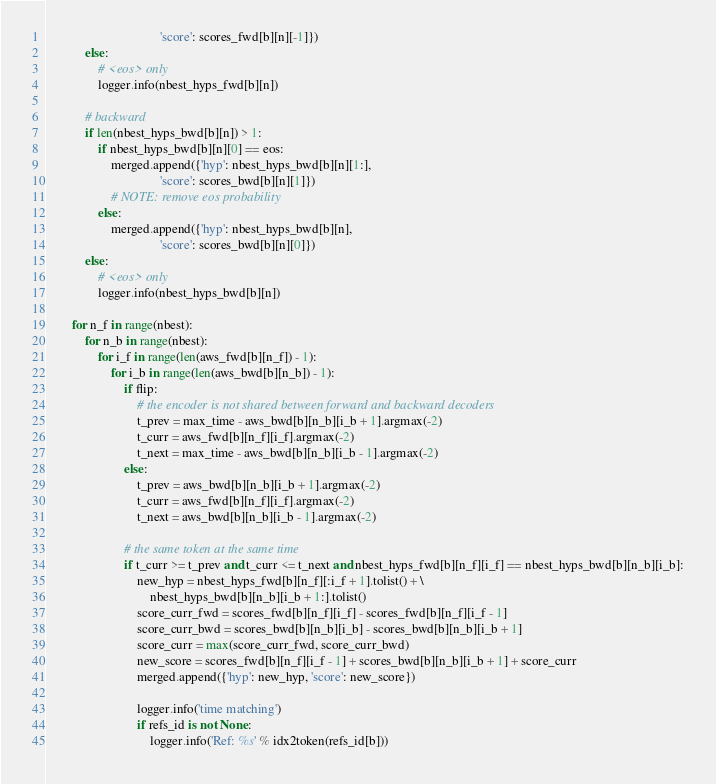Convert code to text. <code><loc_0><loc_0><loc_500><loc_500><_Python_>                                   'score': scores_fwd[b][n][-1]})
            else:
                # <eos> only
                logger.info(nbest_hyps_fwd[b][n])

            # backward
            if len(nbest_hyps_bwd[b][n]) > 1:
                if nbest_hyps_bwd[b][n][0] == eos:
                    merged.append({'hyp': nbest_hyps_bwd[b][n][1:],
                                   'score': scores_bwd[b][n][1]})
                    # NOTE: remove eos probability
                else:
                    merged.append({'hyp': nbest_hyps_bwd[b][n],
                                   'score': scores_bwd[b][n][0]})
            else:
                # <eos> only
                logger.info(nbest_hyps_bwd[b][n])

        for n_f in range(nbest):
            for n_b in range(nbest):
                for i_f in range(len(aws_fwd[b][n_f]) - 1):
                    for i_b in range(len(aws_bwd[b][n_b]) - 1):
                        if flip:
                            # the encoder is not shared between forward and backward decoders
                            t_prev = max_time - aws_bwd[b][n_b][i_b + 1].argmax(-2)
                            t_curr = aws_fwd[b][n_f][i_f].argmax(-2)
                            t_next = max_time - aws_bwd[b][n_b][i_b - 1].argmax(-2)
                        else:
                            t_prev = aws_bwd[b][n_b][i_b + 1].argmax(-2)
                            t_curr = aws_fwd[b][n_f][i_f].argmax(-2)
                            t_next = aws_bwd[b][n_b][i_b - 1].argmax(-2)

                        # the same token at the same time
                        if t_curr >= t_prev and t_curr <= t_next and nbest_hyps_fwd[b][n_f][i_f] == nbest_hyps_bwd[b][n_b][i_b]:
                            new_hyp = nbest_hyps_fwd[b][n_f][:i_f + 1].tolist() + \
                                nbest_hyps_bwd[b][n_b][i_b + 1:].tolist()
                            score_curr_fwd = scores_fwd[b][n_f][i_f] - scores_fwd[b][n_f][i_f - 1]
                            score_curr_bwd = scores_bwd[b][n_b][i_b] - scores_bwd[b][n_b][i_b + 1]
                            score_curr = max(score_curr_fwd, score_curr_bwd)
                            new_score = scores_fwd[b][n_f][i_f - 1] + scores_bwd[b][n_b][i_b + 1] + score_curr
                            merged.append({'hyp': new_hyp, 'score': new_score})

                            logger.info('time matching')
                            if refs_id is not None:
                                logger.info('Ref: %s' % idx2token(refs_id[b]))</code> 